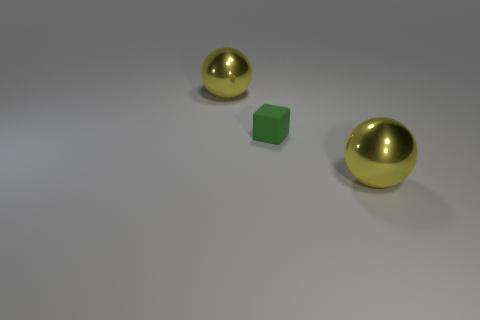What materials do the objects in the image appear to be made from? The objects in the image appear to be of different materials. The two spheres have a shiny, metallic surface suggesting they could be made of polished metal, possibly gold-toned steel or brass, while the cube in the middle has a matte finish, consistent with it being made of rubber or a similarly textured plastic. 